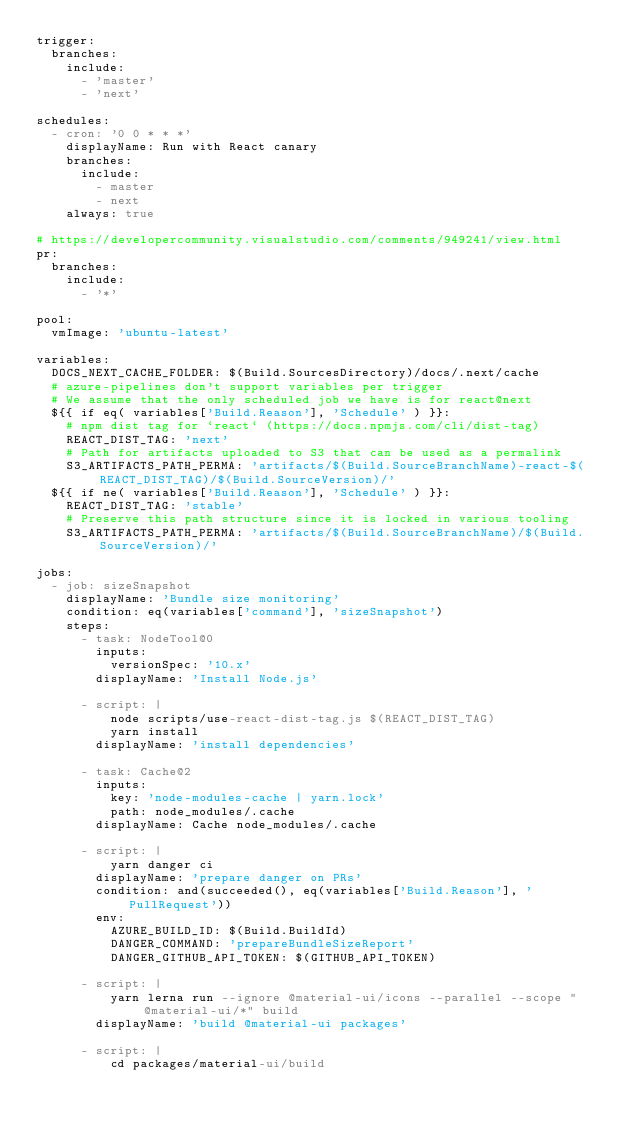<code> <loc_0><loc_0><loc_500><loc_500><_YAML_>trigger:
  branches:
    include:
      - 'master'
      - 'next'

schedules:
  - cron: '0 0 * * *'
    displayName: Run with React canary
    branches:
      include:
        - master
        - next
    always: true

# https://developercommunity.visualstudio.com/comments/949241/view.html
pr:
  branches:
    include:
      - '*'

pool:
  vmImage: 'ubuntu-latest'

variables:
  DOCS_NEXT_CACHE_FOLDER: $(Build.SourcesDirectory)/docs/.next/cache
  # azure-pipelines don't support variables per trigger
  # We assume that the only scheduled job we have is for react@next
  ${{ if eq( variables['Build.Reason'], 'Schedule' ) }}:
    # npm dist tag for `react` (https://docs.npmjs.com/cli/dist-tag)
    REACT_DIST_TAG: 'next'
    # Path for artifacts uploaded to S3 that can be used as a permalink
    S3_ARTIFACTS_PATH_PERMA: 'artifacts/$(Build.SourceBranchName)-react-$(REACT_DIST_TAG)/$(Build.SourceVersion)/'
  ${{ if ne( variables['Build.Reason'], 'Schedule' ) }}:
    REACT_DIST_TAG: 'stable'
    # Preserve this path structure since it is locked in various tooling
    S3_ARTIFACTS_PATH_PERMA: 'artifacts/$(Build.SourceBranchName)/$(Build.SourceVersion)/'

jobs:
  - job: sizeSnapshot
    displayName: 'Bundle size monitoring'
    condition: eq(variables['command'], 'sizeSnapshot')
    steps:
      - task: NodeTool@0
        inputs:
          versionSpec: '10.x'
        displayName: 'Install Node.js'

      - script: |
          node scripts/use-react-dist-tag.js $(REACT_DIST_TAG)
          yarn install
        displayName: 'install dependencies'

      - task: Cache@2
        inputs:
          key: 'node-modules-cache | yarn.lock'
          path: node_modules/.cache
        displayName: Cache node_modules/.cache

      - script: |
          yarn danger ci
        displayName: 'prepare danger on PRs'
        condition: and(succeeded(), eq(variables['Build.Reason'], 'PullRequest'))
        env:
          AZURE_BUILD_ID: $(Build.BuildId)
          DANGER_COMMAND: 'prepareBundleSizeReport'
          DANGER_GITHUB_API_TOKEN: $(GITHUB_API_TOKEN)

      - script: |
          yarn lerna run --ignore @material-ui/icons --parallel --scope "@material-ui/*" build
        displayName: 'build @material-ui packages'

      - script: |
          cd packages/material-ui/build</code> 